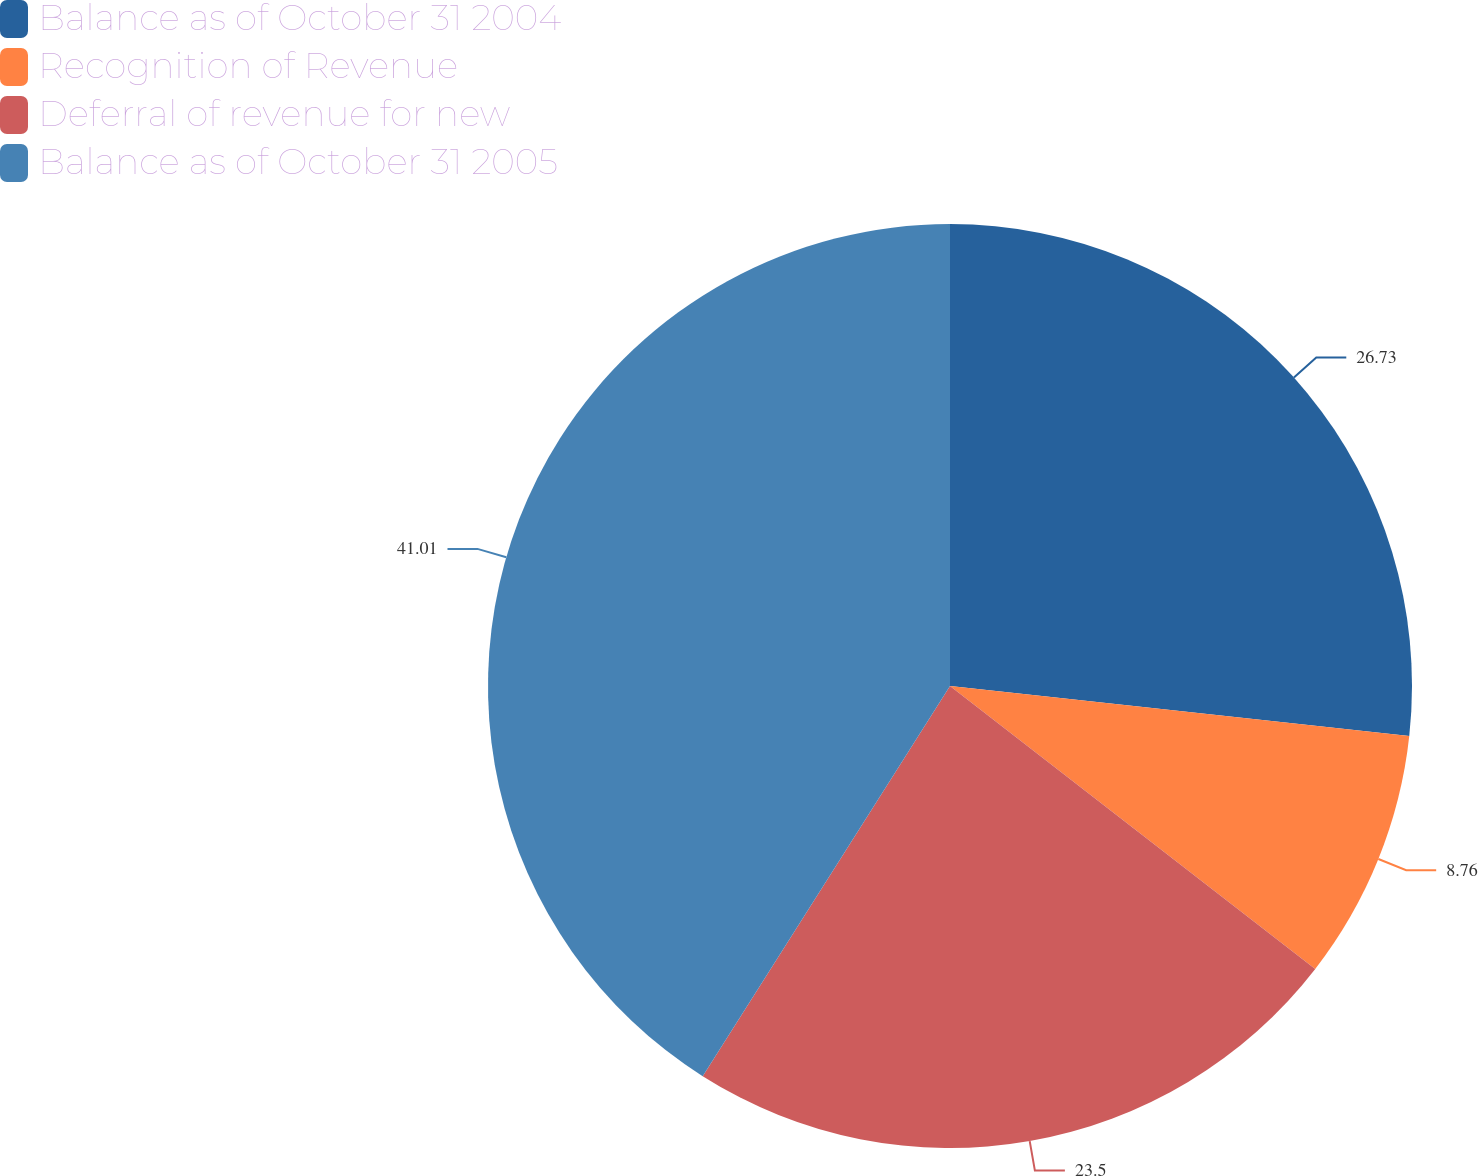<chart> <loc_0><loc_0><loc_500><loc_500><pie_chart><fcel>Balance as of October 31 2004<fcel>Recognition of Revenue<fcel>Deferral of revenue for new<fcel>Balance as of October 31 2005<nl><fcel>26.73%<fcel>8.76%<fcel>23.5%<fcel>41.01%<nl></chart> 